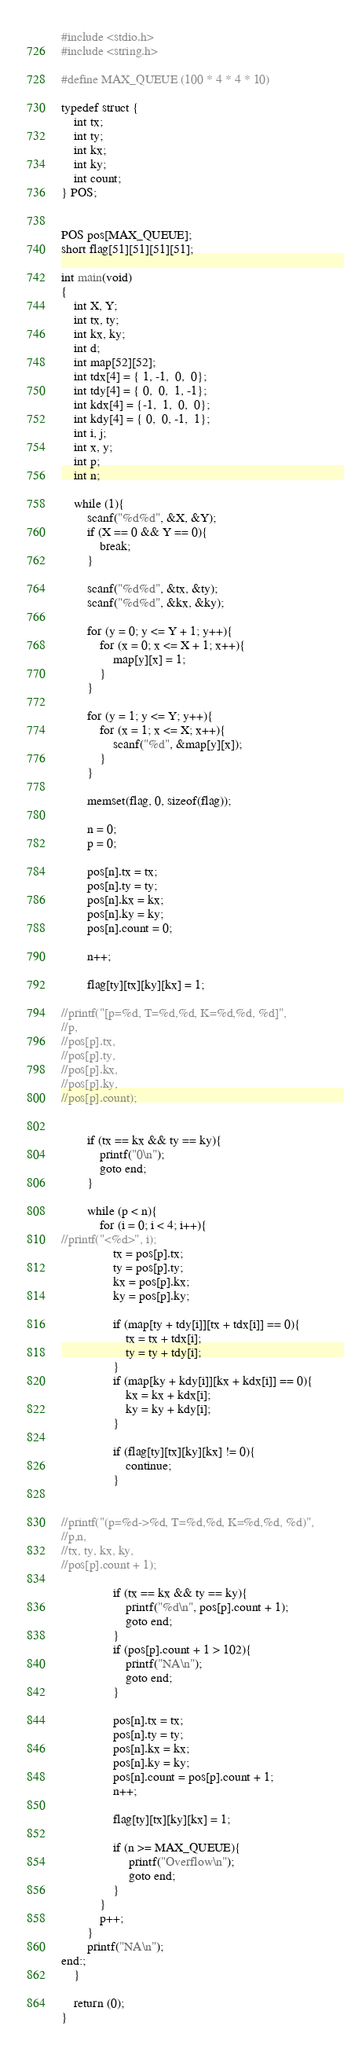<code> <loc_0><loc_0><loc_500><loc_500><_C_>#include <stdio.h>
#include <string.h>

#define MAX_QUEUE (100 * 4 * 4 * 10)

typedef struct {
	int tx;
	int ty;
	int kx;
	int ky;
	int count;
} POS;


POS pos[MAX_QUEUE];
short flag[51][51][51][51];

int main(void)
{
	int X, Y;
	int tx, ty;
	int kx, ky;
	int d;
	int map[52][52];
	int tdx[4] = { 1, -1,  0,  0};
	int tdy[4] = { 0,  0,  1, -1};
	int kdx[4] = {-1,  1,  0,  0};
	int kdy[4] = { 0,  0, -1,  1};
	int i, j;
	int x, y;
	int p;
	int n;
	
	while (1){
		scanf("%d%d", &X, &Y);
		if (X == 0 && Y == 0){
			break;
		}
		
		scanf("%d%d", &tx, &ty);
		scanf("%d%d", &kx, &ky);
		
		for (y = 0; y <= Y + 1; y++){
			for (x = 0; x <= X + 1; x++){
				map[y][x] = 1;
			}
		}

		for (y = 1; y <= Y; y++){
			for (x = 1; x <= X; x++){
				scanf("%d", &map[y][x]);
			}
		}

		memset(flag, 0, sizeof(flag));
		
		n = 0;
		p = 0;
		
		pos[n].tx = tx;
		pos[n].ty = ty;
		pos[n].kx = kx;
		pos[n].ky = ky;
		pos[n].count = 0;
		
		n++;
		
		flag[ty][tx][ky][kx] = 1;

//printf("[p=%d, T=%d,%d, K=%d,%d, %d]", 
//p,
//pos[p].tx,
//pos[p].ty,
//pos[p].kx,
//pos[p].ky,
//pos[p].count);

		
		if (tx == kx && ty == ky){
            printf("0\n");
            goto end;
		}
        
		while (p < n){
			for (i = 0; i < 4; i++){
//printf("<%d>", i);
				tx = pos[p].tx;
				ty = pos[p].ty;
				kx = pos[p].kx;
				ky = pos[p].ky;

				if (map[ty + tdy[i]][tx + tdx[i]] == 0){
					tx = tx + tdx[i];
					ty = ty + tdy[i];
				}
				if (map[ky + kdy[i]][kx + kdx[i]] == 0){
					kx = kx + kdx[i];
					ky = ky + kdy[i];
				}

				if (flag[ty][tx][ky][kx] != 0){
					continue;
				}
				
				
//printf("(p=%d->%d, T=%d,%d, K=%d,%d, %d)", 
//p,n,
//tx, ty, kx, ky,
//pos[p].count + 1);

				if (tx == kx && ty == ky){
        		    printf("%d\n", pos[p].count + 1);
            		goto end;
				}
				if (pos[p].count + 1 > 102){
					printf("NA\n");
					goto end;
				}

				pos[n].tx = tx;
				pos[n].ty = ty;
				pos[n].kx = kx;
				pos[n].ky = ky;
				pos[n].count = pos[p].count + 1;
				n++;

				flag[ty][tx][ky][kx] = 1;
                        
                if (n >= MAX_QUEUE){
                     printf("Overflow\n");
                     goto end;
                }
			}
			p++;
		}
		printf("NA\n");
end:;
	}
	
	return (0);
}</code> 